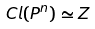<formula> <loc_0><loc_0><loc_500><loc_500>C l ( P ^ { n } ) \simeq Z</formula> 